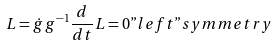<formula> <loc_0><loc_0><loc_500><loc_500>L = \dot { g } \, g ^ { - 1 } \frac { d } { d t } L = 0 " l e f t " s y m m e t r y</formula> 